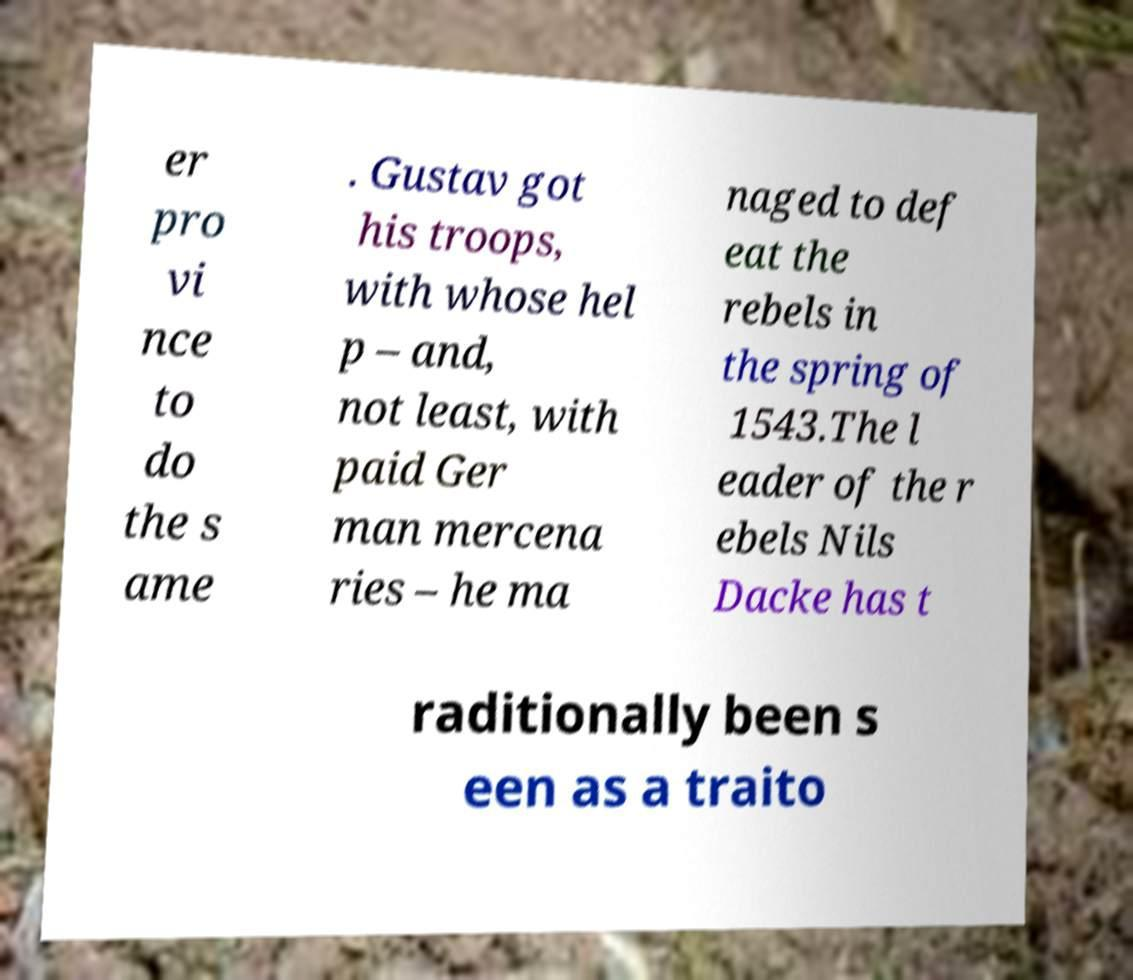Could you extract and type out the text from this image? er pro vi nce to do the s ame . Gustav got his troops, with whose hel p – and, not least, with paid Ger man mercena ries – he ma naged to def eat the rebels in the spring of 1543.The l eader of the r ebels Nils Dacke has t raditionally been s een as a traito 